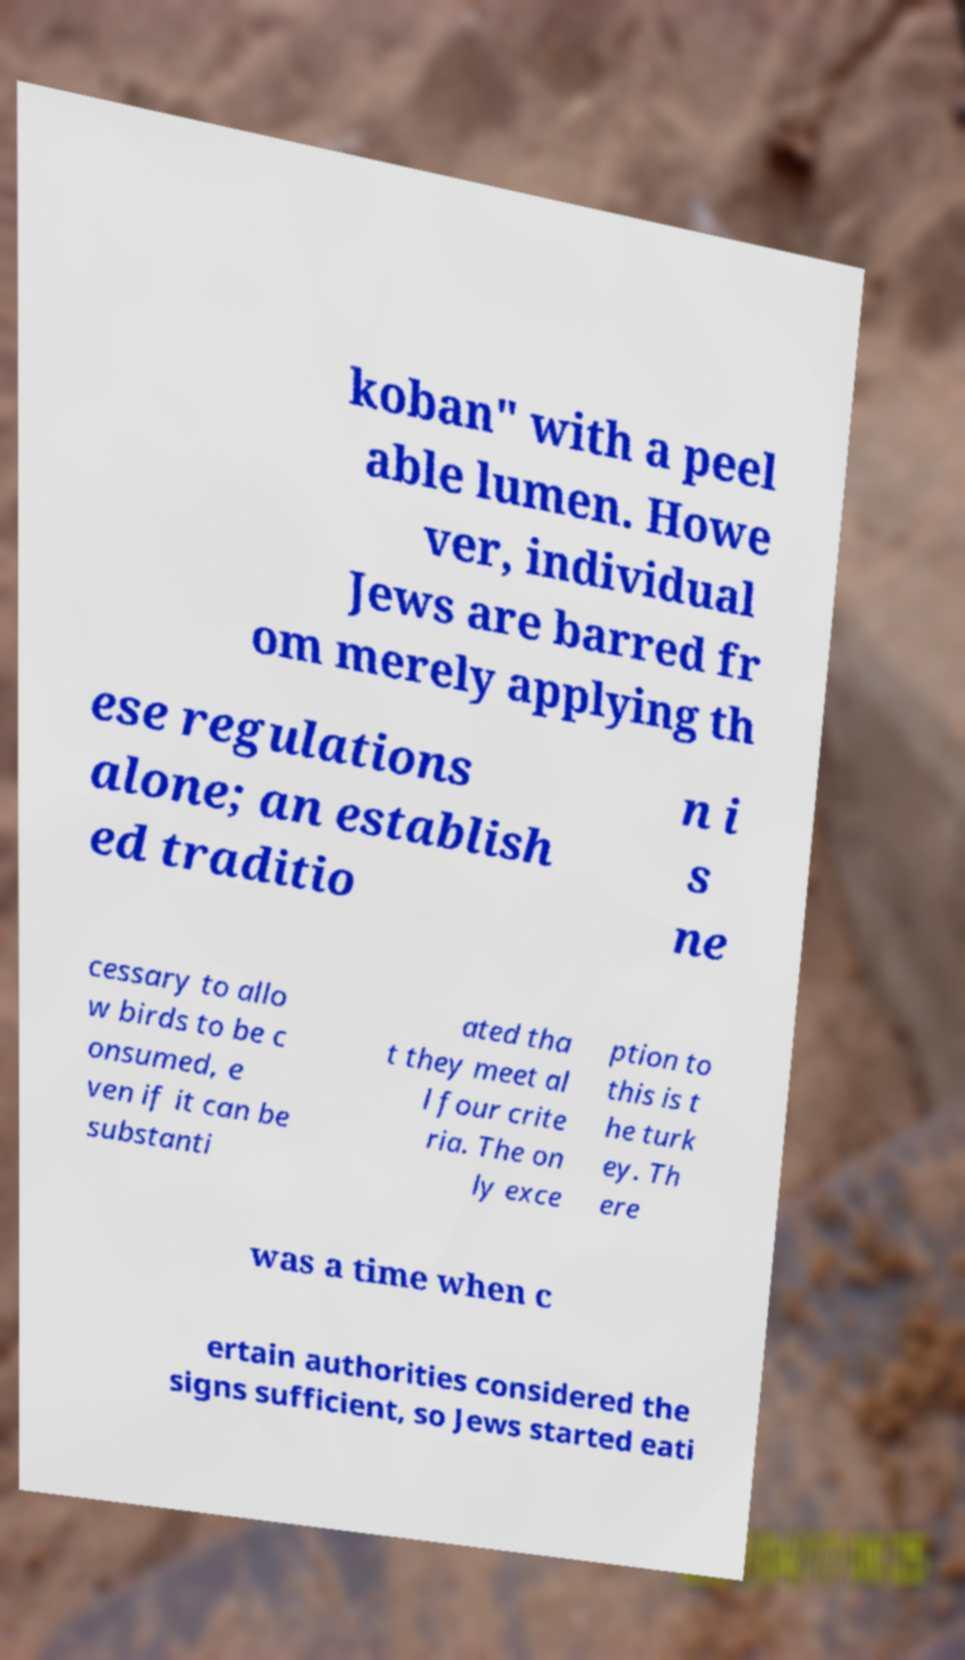What messages or text are displayed in this image? I need them in a readable, typed format. koban" with a peel able lumen. Howe ver, individual Jews are barred fr om merely applying th ese regulations alone; an establish ed traditio n i s ne cessary to allo w birds to be c onsumed, e ven if it can be substanti ated tha t they meet al l four crite ria. The on ly exce ption to this is t he turk ey. Th ere was a time when c ertain authorities considered the signs sufficient, so Jews started eati 